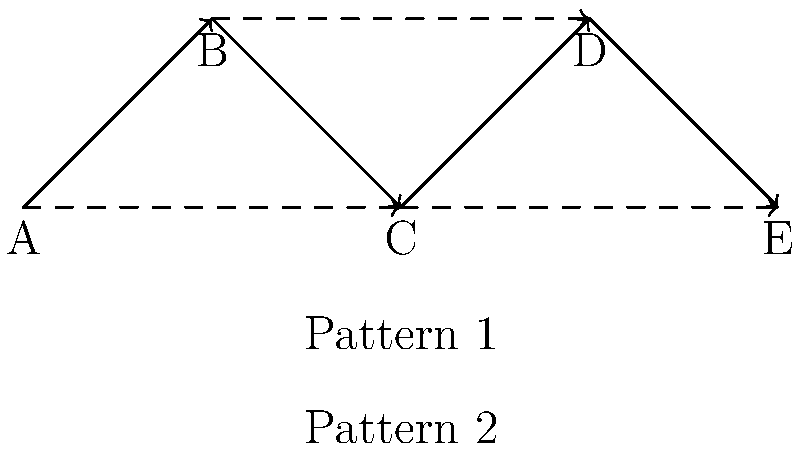Analyze the effectiveness of the two passing patterns shown in the network graph. Pattern 1 is represented by solid arrows, while Pattern 2 is represented by dashed arrows. Consider factors such as defensive pressure, ball progression, and chance creation. Which pattern is likely to be more effective in breaking down a compact defensive formation, and why? To analyze the effectiveness of the two passing patterns, we need to consider several factors:

1. Ball progression:
   Pattern 1 (solid arrows) shows a step-by-step progression from A to E through all players.
   Pattern 2 (dashed arrows) shows longer passes that skip intermediate players.

2. Defensive pressure:
   Pattern 1 allows for shorter passes, which are generally easier to complete under pressure.
   Pattern 2 involves longer passes, which may be riskier but can bypass pressing opponents.

3. Chance creation:
   Pattern 1 may be slower but allows for more intricate build-up play.
   Pattern 2 can quickly advance the ball into dangerous areas, potentially catching defenders out of position.

4. Compactness of defensive formation:
   Against a compact defense, Pattern 1 might struggle to find space between the lines.
   Pattern 2 can potentially bypass lines of defense, stretching the compact formation.

5. Unpredictability:
   Pattern 1 is more predictable but safer.
   Pattern 2 offers more variety and unpredictability in passing options.

6. Player involvement:
   Pattern 1 involves all players, potentially dragging defenders out of position.
   Pattern 2 bypasses some players, which could leave them in space to receive subsequent passes.

Considering these factors, Pattern 2 is likely to be more effective in breaking down a compact defensive formation. The longer passes can quickly shift the point of attack, forcing the defense to readjust rapidly. This can create gaps in the defensive structure, especially if executed with precision and good off-ball movement from attacking players. Additionally, the unpredictability of Pattern 2 makes it harder for defenders to anticipate and intercept passes.

However, it's important to note that a combination of both patterns would likely be most effective in practice, allowing the team to adapt to different defensive scenarios and maintain unpredictability in their attacking play.
Answer: Pattern 2, due to its ability to bypass defensive lines quickly and create unpredictability. 